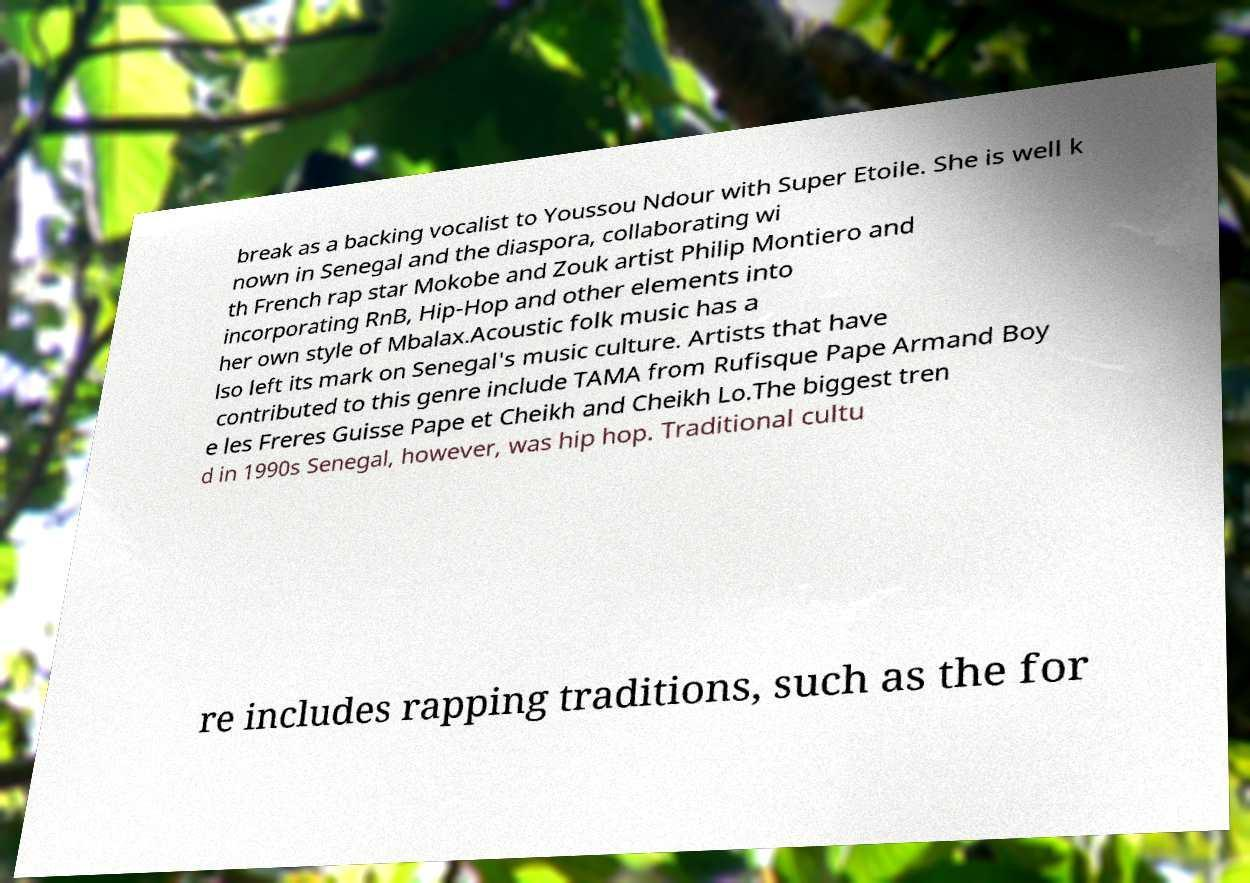Can you accurately transcribe the text from the provided image for me? break as a backing vocalist to Youssou Ndour with Super Etoile. She is well k nown in Senegal and the diaspora, collaborating wi th French rap star Mokobe and Zouk artist Philip Montiero and incorporating RnB, Hip-Hop and other elements into her own style of Mbalax.Acoustic folk music has a lso left its mark on Senegal's music culture. Artists that have contributed to this genre include TAMA from Rufisque Pape Armand Boy e les Freres Guisse Pape et Cheikh and Cheikh Lo.The biggest tren d in 1990s Senegal, however, was hip hop. Traditional cultu re includes rapping traditions, such as the for 